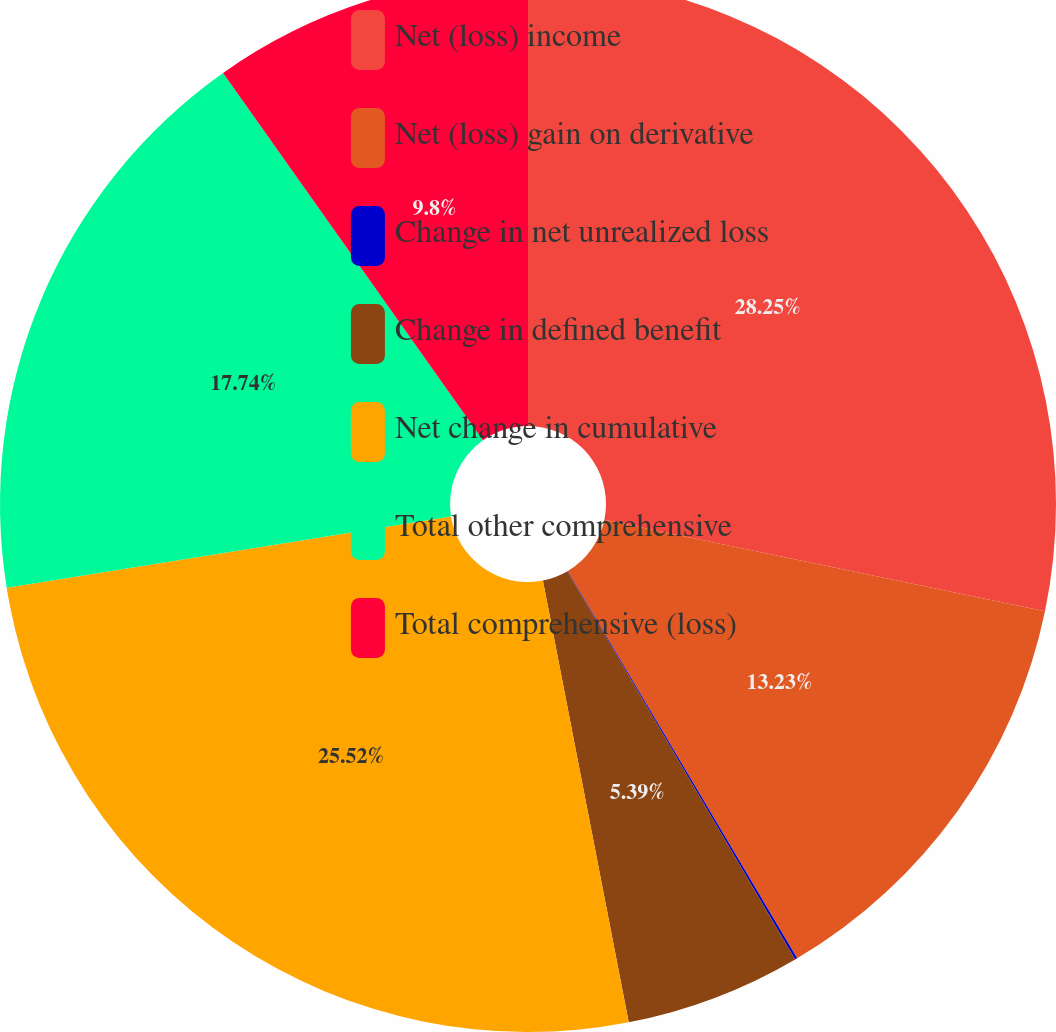<chart> <loc_0><loc_0><loc_500><loc_500><pie_chart><fcel>Net (loss) income<fcel>Net (loss) gain on derivative<fcel>Change in net unrealized loss<fcel>Change in defined benefit<fcel>Net change in cumulative<fcel>Total other comprehensive<fcel>Total comprehensive (loss)<nl><fcel>28.26%<fcel>13.23%<fcel>0.07%<fcel>5.39%<fcel>25.52%<fcel>17.74%<fcel>9.8%<nl></chart> 